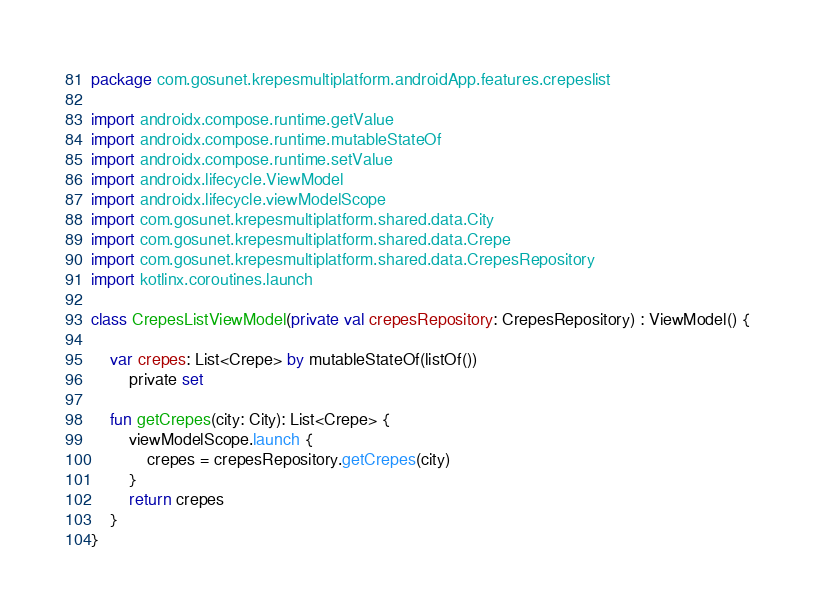<code> <loc_0><loc_0><loc_500><loc_500><_Kotlin_>package com.gosunet.krepesmultiplatform.androidApp.features.crepeslist

import androidx.compose.runtime.getValue
import androidx.compose.runtime.mutableStateOf
import androidx.compose.runtime.setValue
import androidx.lifecycle.ViewModel
import androidx.lifecycle.viewModelScope
import com.gosunet.krepesmultiplatform.shared.data.City
import com.gosunet.krepesmultiplatform.shared.data.Crepe
import com.gosunet.krepesmultiplatform.shared.data.CrepesRepository
import kotlinx.coroutines.launch

class CrepesListViewModel(private val crepesRepository: CrepesRepository) : ViewModel() {

    var crepes: List<Crepe> by mutableStateOf(listOf())
        private set

    fun getCrepes(city: City): List<Crepe> {
        viewModelScope.launch {
            crepes = crepesRepository.getCrepes(city)
        }
        return crepes
    }
}
</code> 